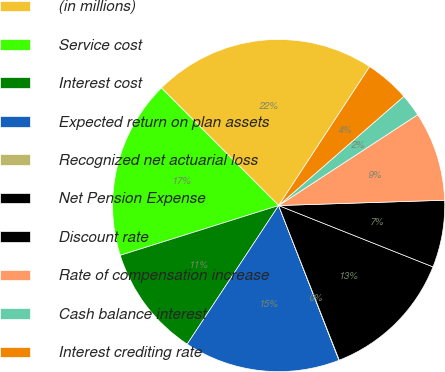Convert chart. <chart><loc_0><loc_0><loc_500><loc_500><pie_chart><fcel>(in millions)<fcel>Service cost<fcel>Interest cost<fcel>Expected return on plan assets<fcel>Recognized net actuarial loss<fcel>Net Pension Expense<fcel>Discount rate<fcel>Rate of compensation increase<fcel>Cash balance interest<fcel>Interest crediting rate<nl><fcel>21.7%<fcel>17.37%<fcel>10.87%<fcel>15.2%<fcel>0.03%<fcel>13.03%<fcel>6.53%<fcel>8.7%<fcel>2.2%<fcel>4.36%<nl></chart> 